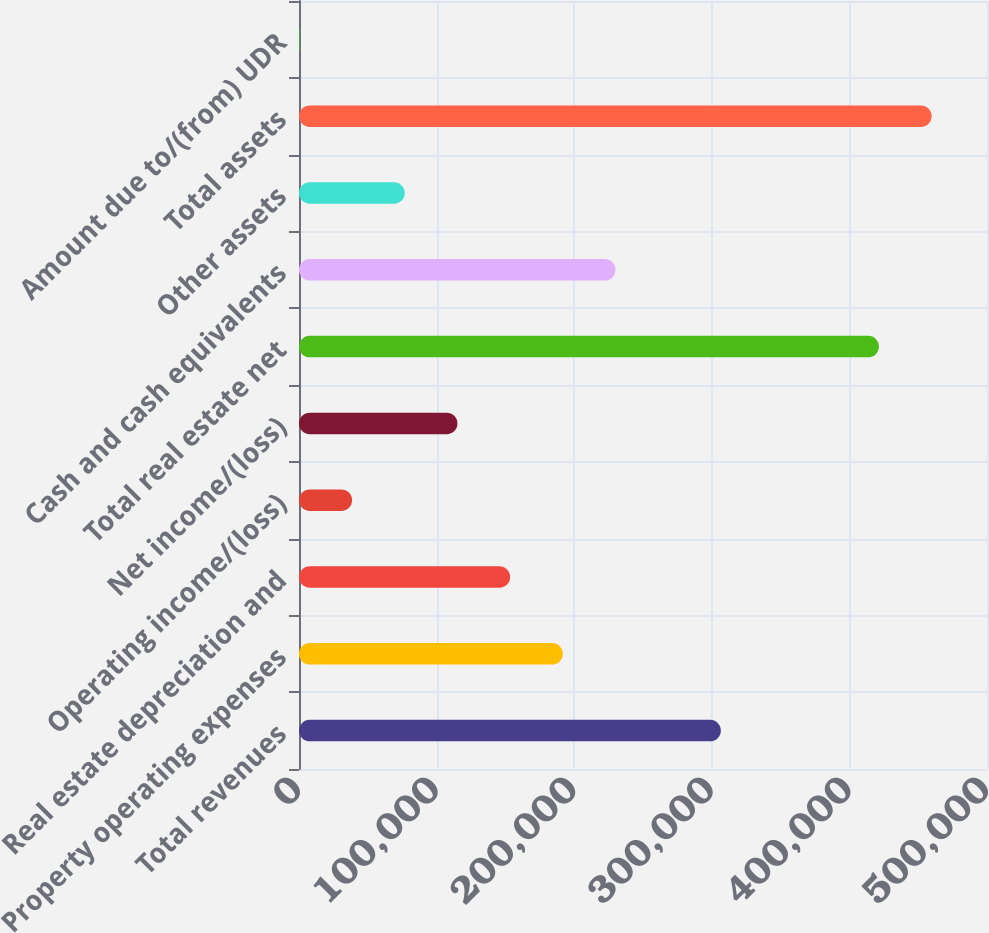Convert chart. <chart><loc_0><loc_0><loc_500><loc_500><bar_chart><fcel>Total revenues<fcel>Property operating expenses<fcel>Real estate depreciation and<fcel>Operating income/(loss)<fcel>Net income/(loss)<fcel>Total real estate net<fcel>Cash and cash equivalents<fcel>Other assets<fcel>Total assets<fcel>Amount due to/(from) UDR<nl><fcel>306586<fcel>191719<fcel>153430<fcel>38563<fcel>115141<fcel>421453<fcel>230008<fcel>76852<fcel>459742<fcel>274<nl></chart> 